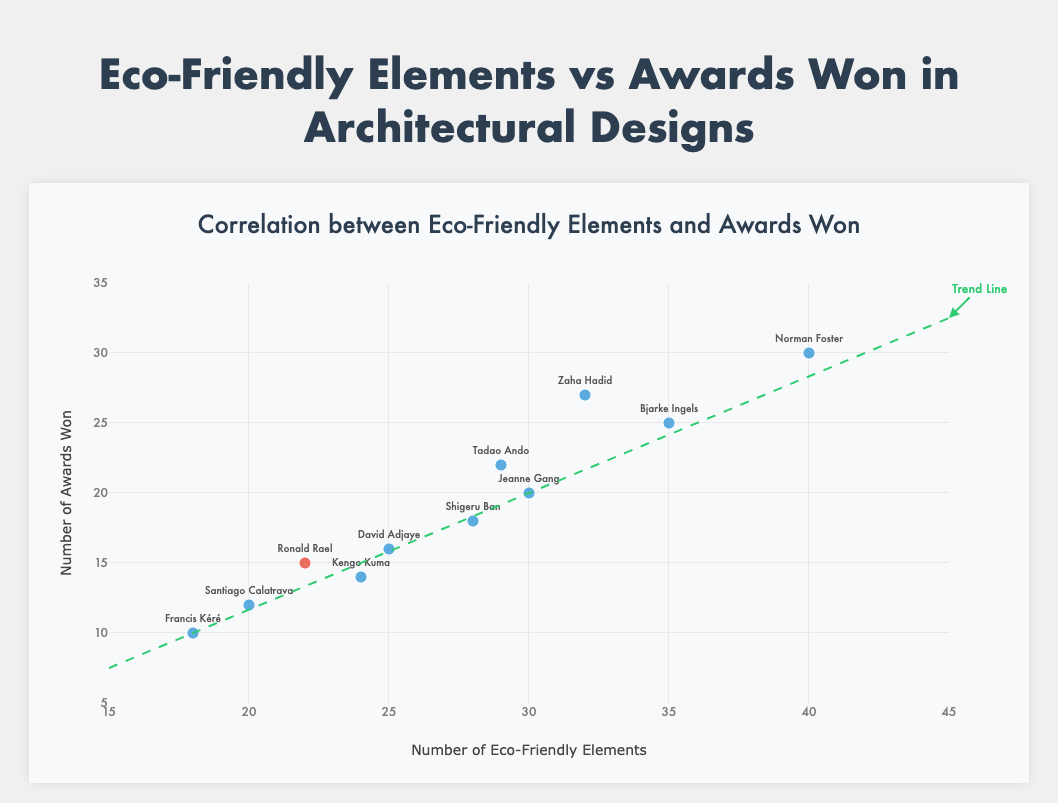What is the title of the figure? The title is displayed prominently at the top of the figure, reading "Eco-Friendly Elements vs Awards Won in Architectural Designs".
Answer: Eco-Friendly Elements vs Awards Won in Architectural Designs How many architects are included in the figure? By counting the unique names labeled next to data points, there are 11 architects shown in the figure.
Answer: 11 What color are the data points corresponding to Ronald Rael? The data points for Ronald Rael are distinctly colored to stand out, which is red.
Answer: Red What is the range of the x-axis? The x-axis, representing the number of eco-friendly elements, ranges from 15 to 45 as shown by the axis ticks.
Answer: 15 to 45 Which architect has the maximum number of eco-friendly elements used in their designs? By looking at the horizontal placement of data points, Norman Foster has the most eco-friendly elements with 40.
Answer: Norman Foster Which architect has won the most awards? By examining the vertical placement of data points, Norman Foster has won the most awards, totaling 30.
Answer: Norman Foster Calculate the average number of awards won by all architects. Sum all awards won: 15+20+25+10+18+14+30+27+12+22+16 = 209, then divide by the number of architects (11). The average is 209/11.
Answer: 19 How does Ronald Rael's number of eco-friendly elements compare to the architect with the least eco-friendly elements? Ronald Rael uses 22 eco-friendly elements, whereas Francis Kéré uses the least with 18 eco-friendly elements, making Ronald Rael use 4 more.
Answer: 4 more What is the correlation between the number of eco-friendly elements and awards won? The trend line in the figure suggests a positive correlation, indicating that as the number of eco-friendly elements increases, the number of awards won also tends to increase.
Answer: Positive Which architect has the most awards among those who have fewer eco-friendly elements than Ronald Rael? Ronald Rael has 22 eco-friendly elements. The architect with fewer elements but more awards is Santiago Calatrava, with 12 elements and 12 awards.
Answer: Santiago Calatrava 